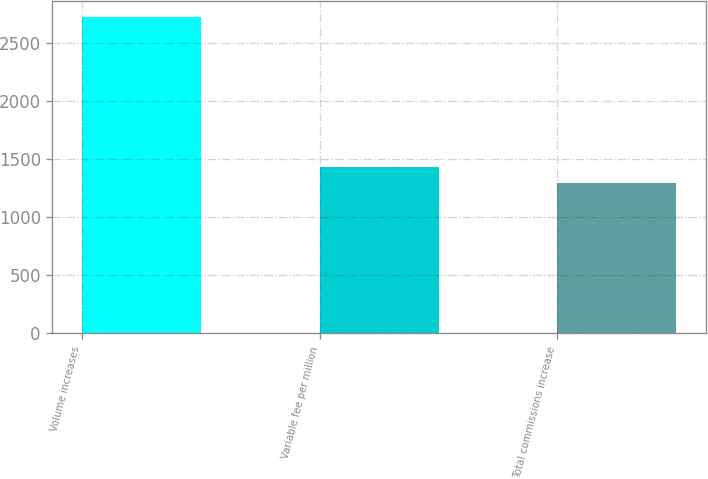Convert chart to OTSL. <chart><loc_0><loc_0><loc_500><loc_500><bar_chart><fcel>Volume increases<fcel>Variable fee per million<fcel>Total commissions increase<nl><fcel>2724<fcel>1434<fcel>1290<nl></chart> 